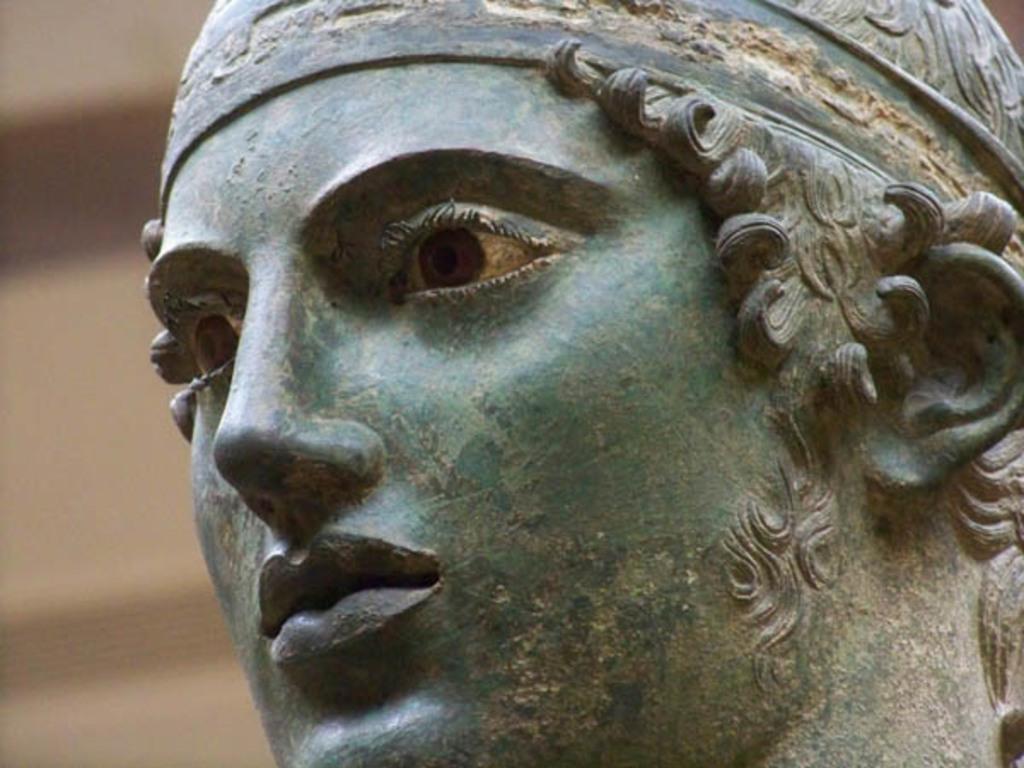Describe this image in one or two sentences. This is a close up image of a person's sculpture and the background is blurred. 